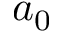<formula> <loc_0><loc_0><loc_500><loc_500>a _ { 0 }</formula> 